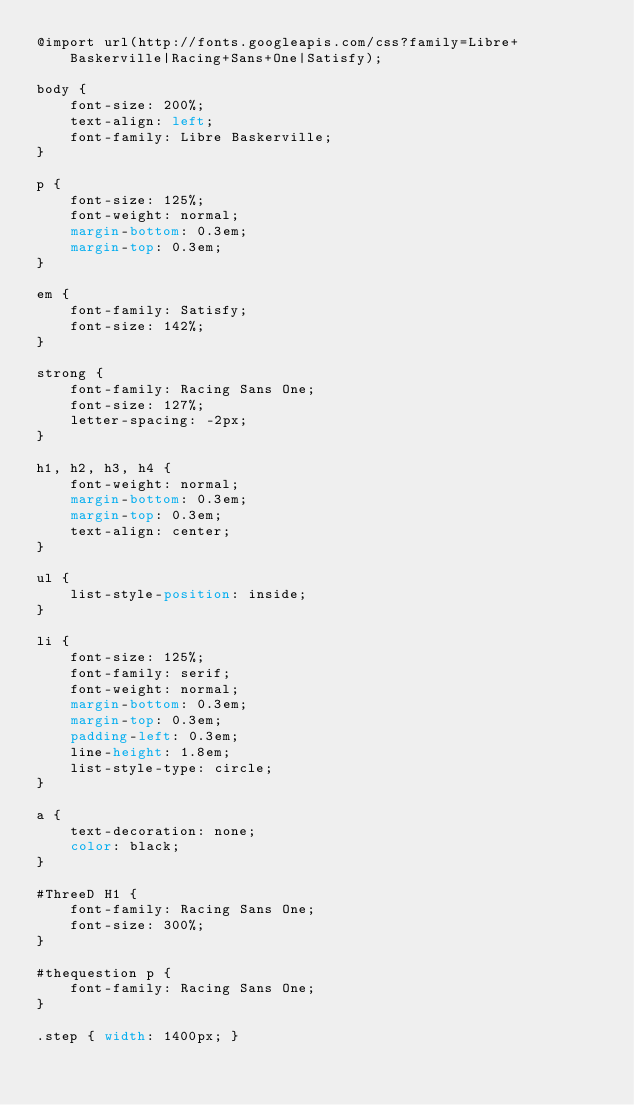<code> <loc_0><loc_0><loc_500><loc_500><_CSS_>@import url(http://fonts.googleapis.com/css?family=Libre+Baskerville|Racing+Sans+One|Satisfy);

body {
    font-size: 200%;
    text-align: left;
    font-family: Libre Baskerville;
}

p {
    font-size: 125%;
    font-weight: normal;
    margin-bottom: 0.3em;
    margin-top: 0.3em;
}

em {
    font-family: Satisfy;
    font-size: 142%;
}

strong {
    font-family: Racing Sans One;
    font-size: 127%;
    letter-spacing: -2px;
}

h1, h2, h3, h4 {
    font-weight: normal;
    margin-bottom: 0.3em;
    margin-top: 0.3em;
    text-align: center;
}

ul {
    list-style-position: inside;
}

li {
    font-size: 125%;
    font-family: serif;
    font-weight: normal;
    margin-bottom: 0.3em;
    margin-top: 0.3em;
    padding-left: 0.3em;
    line-height: 1.8em;
    list-style-type: circle;
}

a {
    text-decoration: none;
    color: black;
}

#ThreeD H1 {
    font-family: Racing Sans One;
    font-size: 300%;
}

#thequestion p {
    font-family: Racing Sans One;
}

.step { width: 1400px; }
</code> 